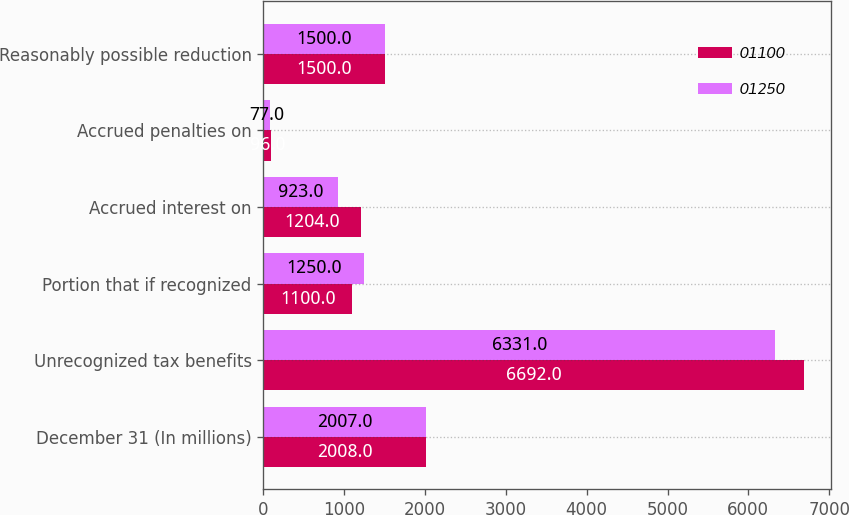<chart> <loc_0><loc_0><loc_500><loc_500><stacked_bar_chart><ecel><fcel>December 31 (In millions)<fcel>Unrecognized tax benefits<fcel>Portion that if recognized<fcel>Accrued interest on<fcel>Accrued penalties on<fcel>Reasonably possible reduction<nl><fcel>1100<fcel>2008<fcel>6692<fcel>1100<fcel>1204<fcel>96<fcel>1500<nl><fcel>1250<fcel>2007<fcel>6331<fcel>1250<fcel>923<fcel>77<fcel>1500<nl></chart> 